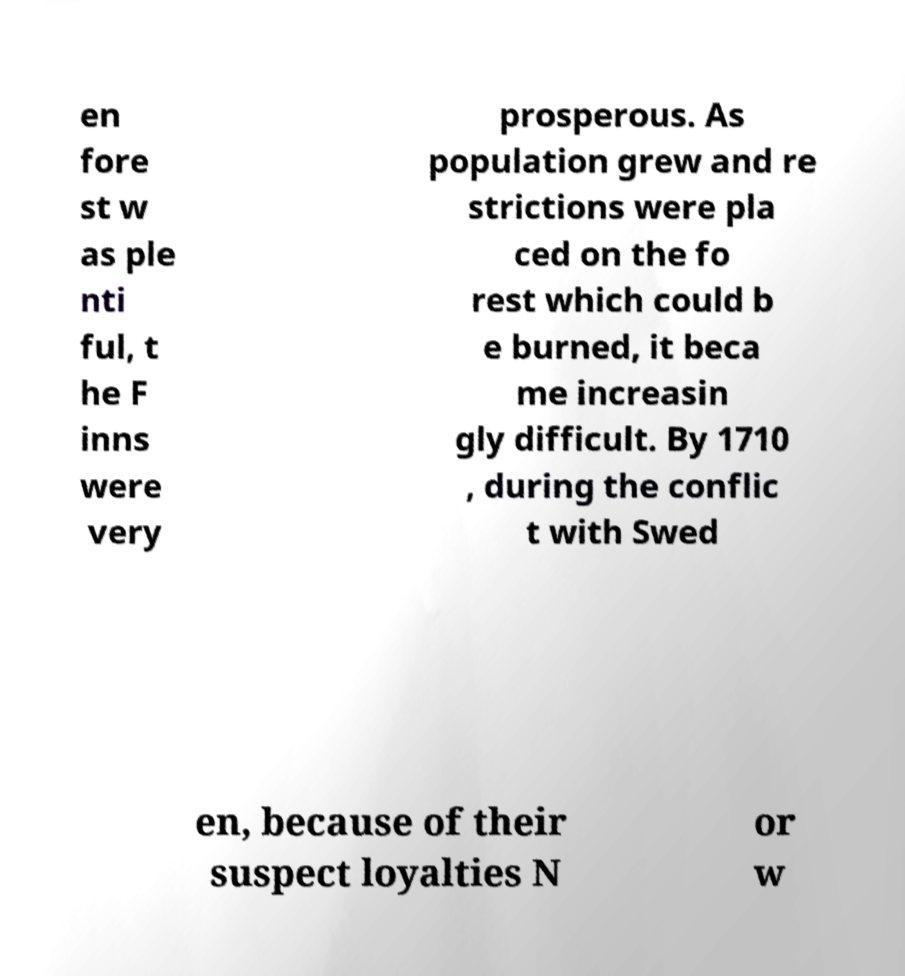Could you extract and type out the text from this image? en fore st w as ple nti ful, t he F inns were very prosperous. As population grew and re strictions were pla ced on the fo rest which could b e burned, it beca me increasin gly difficult. By 1710 , during the conflic t with Swed en, because of their suspect loyalties N or w 